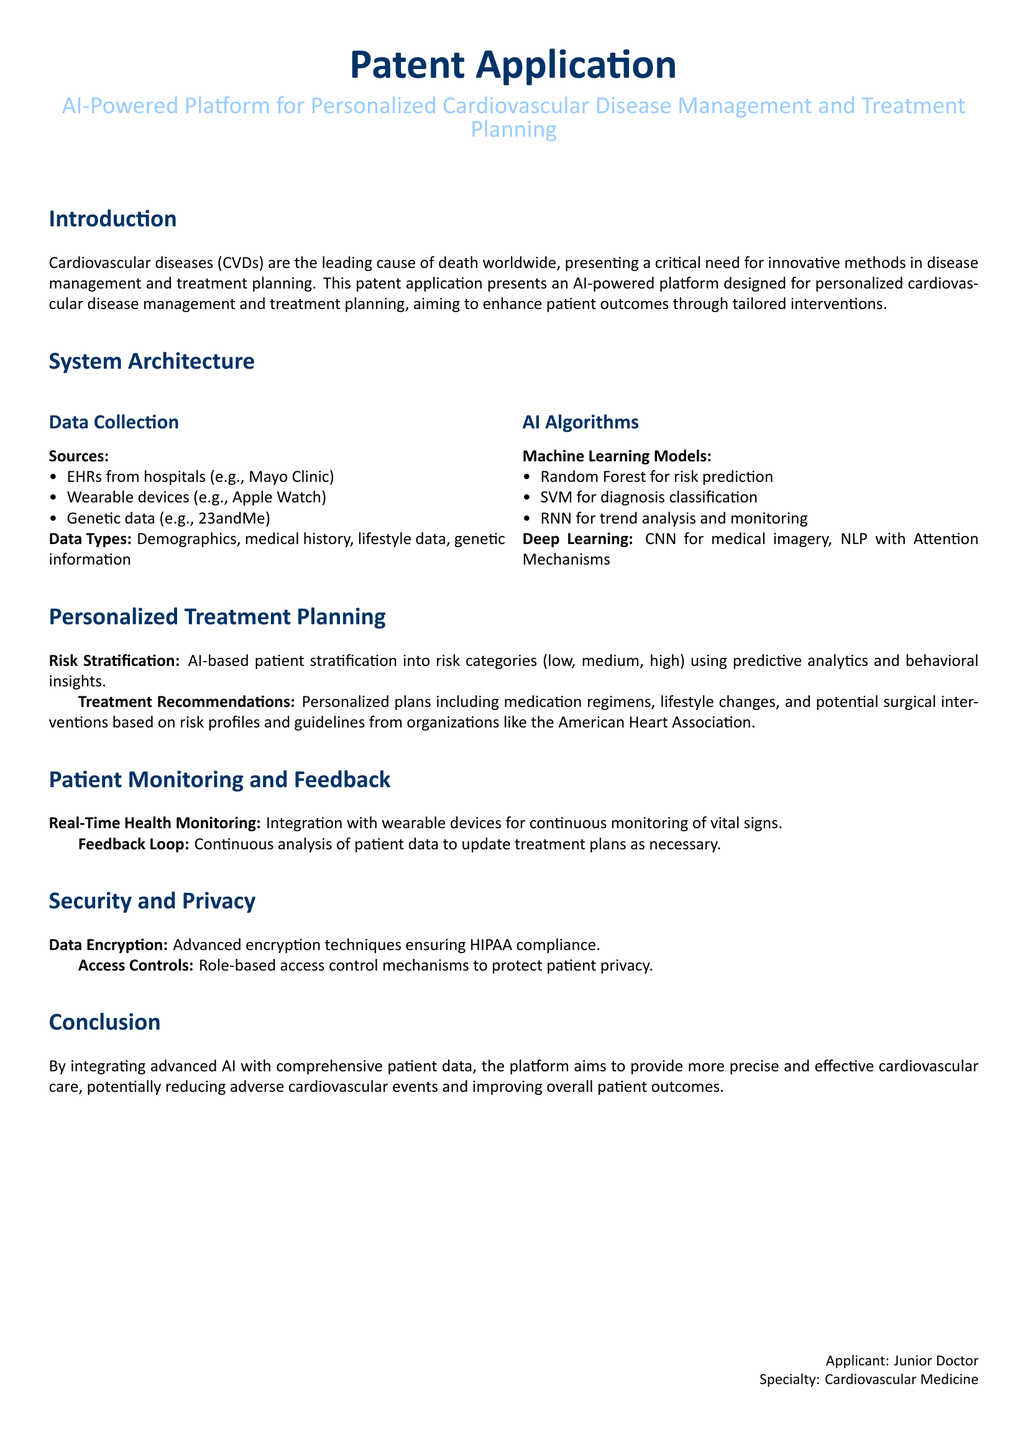What is the leading cause of death worldwide? Cardiovascular diseases are identified as the leading cause of death globally in the document.
Answer: Cardiovascular diseases What are the sources of data for the AI-powered platform? The document lists EHRs from hospitals, wearable devices, and genetic data as sources of data.
Answer: EHRs, wearable devices, genetic data What machine learning model is used for risk prediction? The Random Forest model is specified for risk prediction within the AI algorithms section.
Answer: Random Forest What organization’s guidelines does the platform refer to for treatment recommendations? The platform references the American Heart Association for treatment recommendations in its planning section.
Answer: American Heart Association What type of monitoring does the AI-powered platform provide? The platform provides real-time health monitoring as mentioned in the patient monitoring section.
Answer: Real-time health monitoring What is the purpose of the feedback loop in the platform? The feedback loop is intended for continuous analysis of patient data to update treatment plans as necessary.
Answer: Update treatment plans What technology ensures HIPAA compliance? The document states that advanced encryption techniques are used to ensure HIPAA compliance.
Answer: Advanced encryption techniques What patient stratification categories are mentioned? The categories for patient stratification identified are low, medium, and high.
Answer: Low, medium, high What document type does this text represent? This text is a patent application, as stated in the title section.
Answer: Patent application 